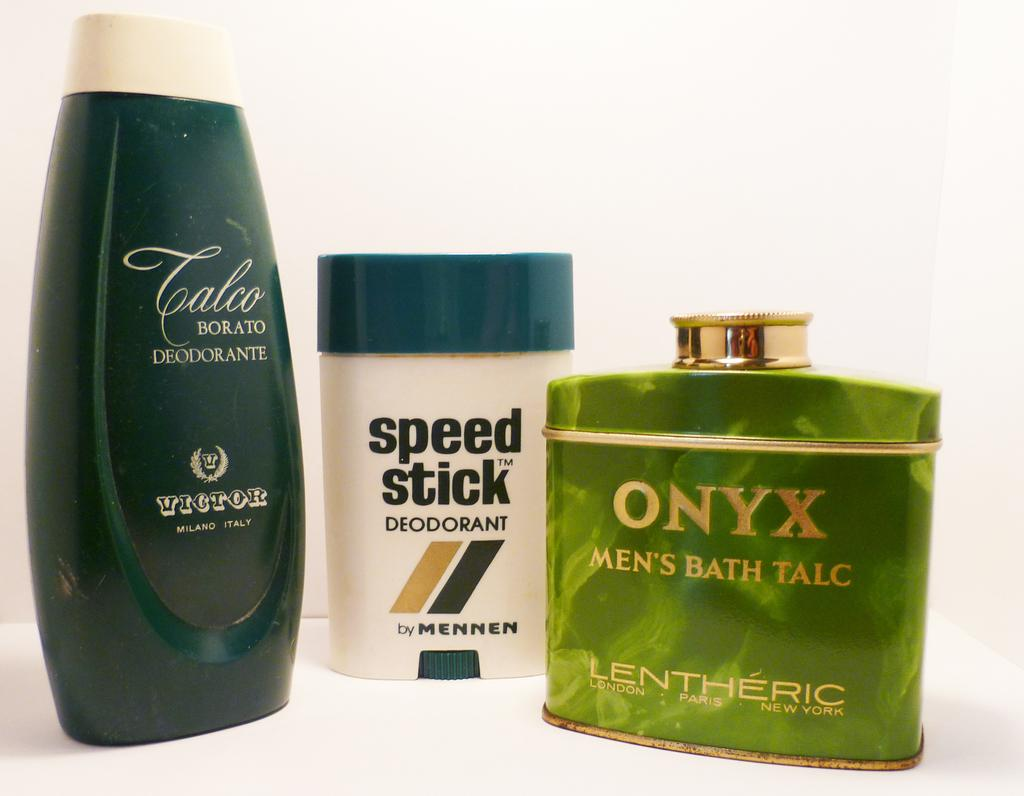Provide a one-sentence caption for the provided image. a green cologne bottle with the word Onyx on it. 